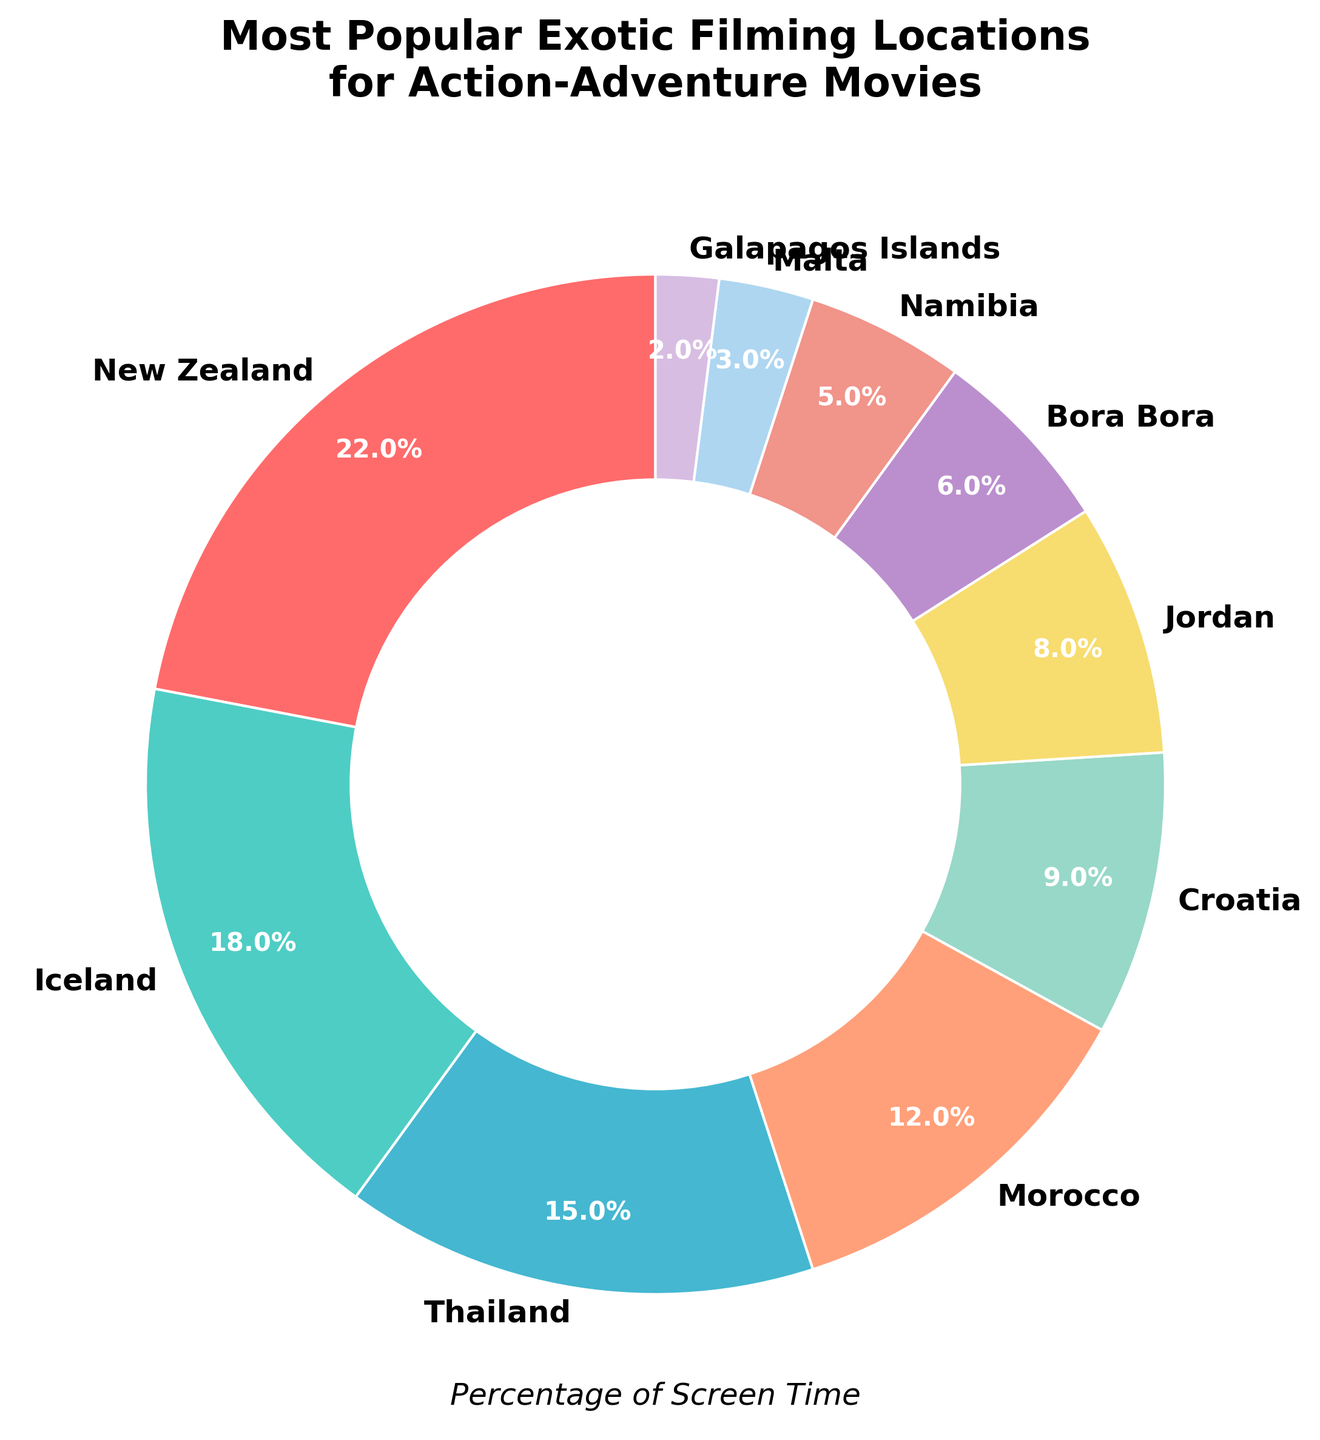What location has the highest percentage of screen time? Identify the segment with the largest percentage label. The largest segment is labeled "New Zealand" with 22%.
Answer: New Zealand What location has the second highest percentage of screen time? Identify the segment with the second largest percentage label. The second largest segment is labeled "Iceland" with 18%.
Answer: Iceland Which locations together constitute more than half of the total screen time? Sum the percentages of locations starting from the highest until the total exceeds 50%. New Zealand (22%) + Iceland (18%) + Thailand (15%) = 55%.
Answer: New Zealand, Iceland, Thailand How much more screen time does New Zealand have compared to Morocco? Subtract the percentage of Morocco from that of New Zealand. New Zealand (22%) - Morocco (12%) = 10%.
Answer: 10% Which location has the least percentage of screen time, and what is it? Identify the segment with the smallest percentage label. The smallest segment is labeled "Galapagos Islands" with 2%.
Answer: Galapagos Islands Compare the screen time of Thailand and Malta. Which is more and by how much? Subtract the percentage of Malta from that of Thailand. Thailand (15%) - Malta (3%) = 12%.
Answer: Thailand, 12% What is the combined percentage of screen time for Bora Bora, Namibia, and Malta? Add the percentages of Bora Bora, Namibia, and Malta. Bora Bora (6%) + Namibia (5%) + Malta (3%) = 14%.
Answer: 14% Which has more screen time: Jordan or Croatia? Compare the percentages of Jordan and Croatia. Croatia has 9% and Jordan has 8%. Therefore, Croatia has more screen time.
Answer: Croatia Calculate the average screen time percentage for the top three locations. Sum the percentages of the top three locations and divide by three. (New Zealand 22% + Iceland 18% + Thailand 15%) / 3 = 18.33%.
Answer: 18.33% Identify the color associated with Iceland. Observe the visual color representing the segment labeled "Iceland" in the pie chart. The color is different shades of blue and green due to custom palette usage.
Answer: A shade of green Which location's screen time is exactly half of Thailand's screen time? Identify the location with a percentage exactly half of 15%. Bora Bora has 6%, which is not half, but no location fits the exact criteria.
Answer: None 